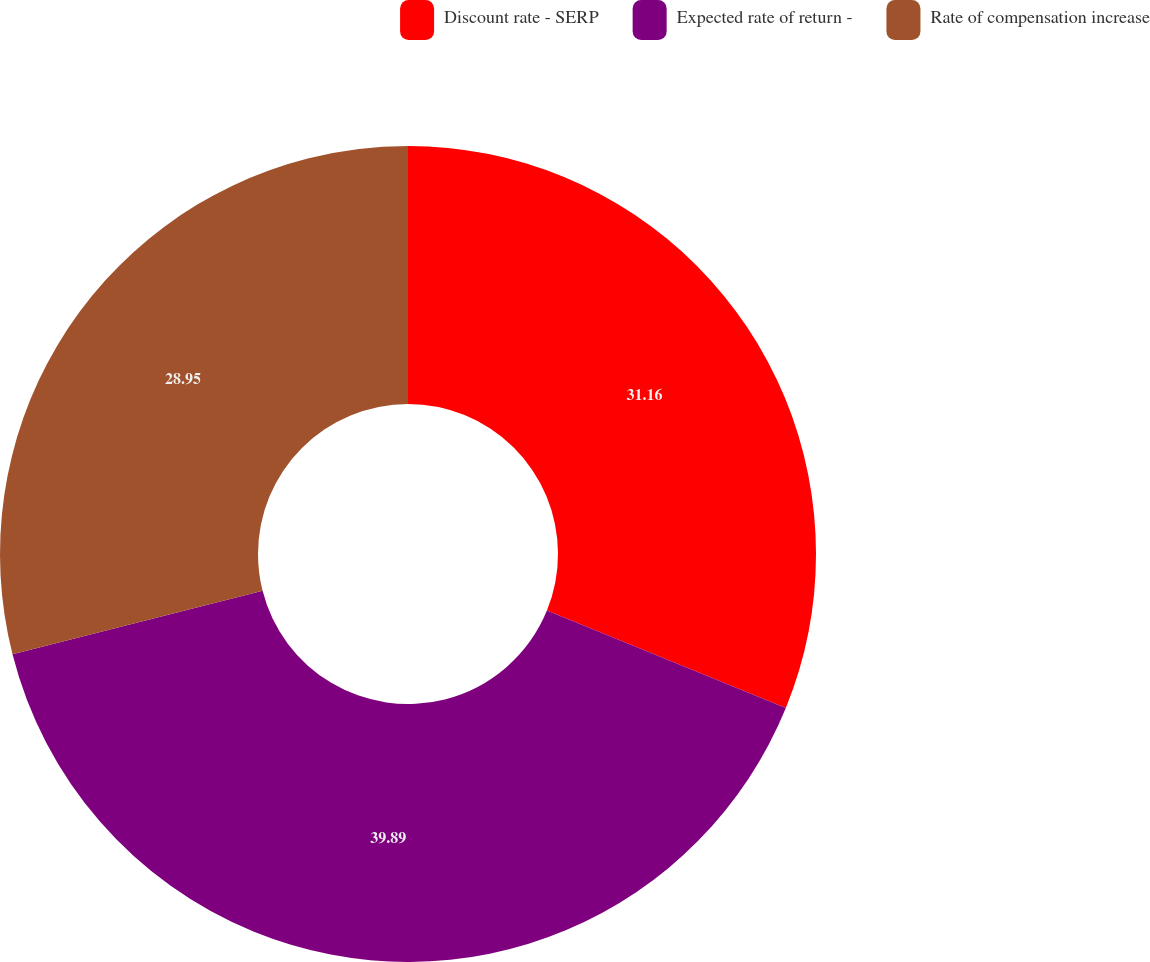Convert chart. <chart><loc_0><loc_0><loc_500><loc_500><pie_chart><fcel>Discount rate - SERP<fcel>Expected rate of return -<fcel>Rate of compensation increase<nl><fcel>31.16%<fcel>39.89%<fcel>28.95%<nl></chart> 